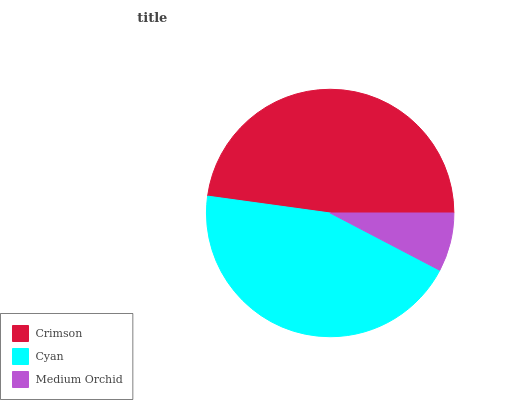Is Medium Orchid the minimum?
Answer yes or no. Yes. Is Crimson the maximum?
Answer yes or no. Yes. Is Cyan the minimum?
Answer yes or no. No. Is Cyan the maximum?
Answer yes or no. No. Is Crimson greater than Cyan?
Answer yes or no. Yes. Is Cyan less than Crimson?
Answer yes or no. Yes. Is Cyan greater than Crimson?
Answer yes or no. No. Is Crimson less than Cyan?
Answer yes or no. No. Is Cyan the high median?
Answer yes or no. Yes. Is Cyan the low median?
Answer yes or no. Yes. Is Crimson the high median?
Answer yes or no. No. Is Crimson the low median?
Answer yes or no. No. 